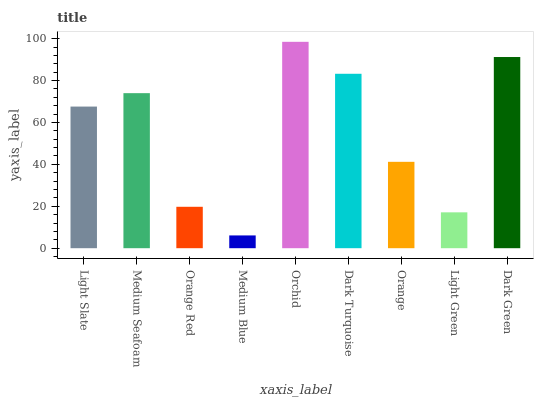Is Medium Blue the minimum?
Answer yes or no. Yes. Is Orchid the maximum?
Answer yes or no. Yes. Is Medium Seafoam the minimum?
Answer yes or no. No. Is Medium Seafoam the maximum?
Answer yes or no. No. Is Medium Seafoam greater than Light Slate?
Answer yes or no. Yes. Is Light Slate less than Medium Seafoam?
Answer yes or no. Yes. Is Light Slate greater than Medium Seafoam?
Answer yes or no. No. Is Medium Seafoam less than Light Slate?
Answer yes or no. No. Is Light Slate the high median?
Answer yes or no. Yes. Is Light Slate the low median?
Answer yes or no. Yes. Is Orange Red the high median?
Answer yes or no. No. Is Orange the low median?
Answer yes or no. No. 